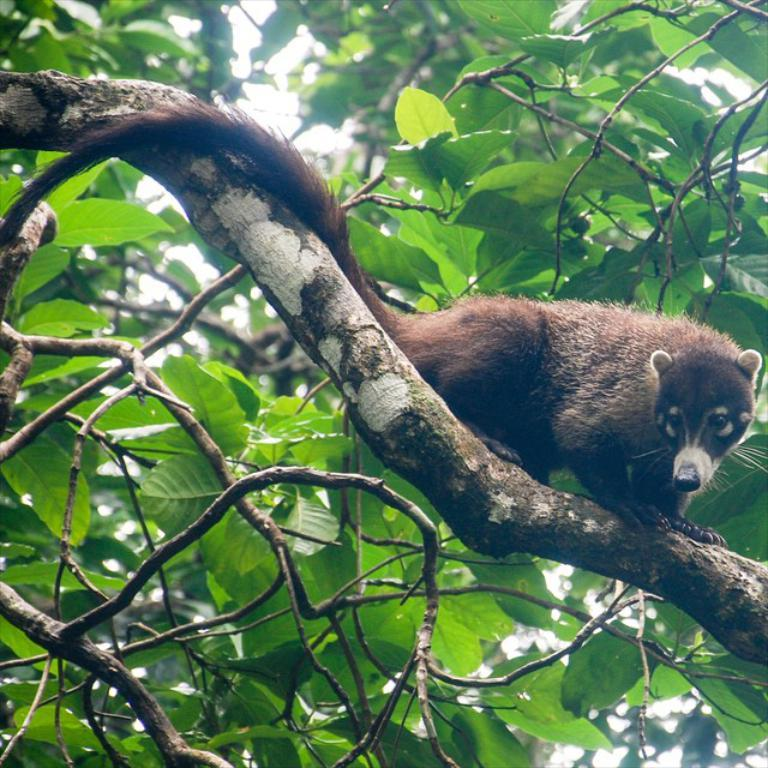What type of animal is present in the image? There is an animal in the image, but the specific type cannot be determined from the provided facts. Where is the animal located in the image? The animal is on a tree in the image. What color is the bubble floating near the animal? There is no bubble present in the image. How many rings can be seen around the animal's neck? There are no rings visible around the animal's neck in the image. 